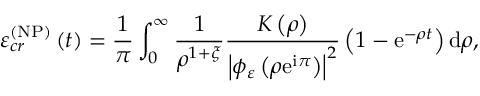<formula> <loc_0><loc_0><loc_500><loc_500>\varepsilon _ { c r } ^ { \left ( N P \right ) } \left ( t \right ) = \frac { 1 } { \pi } \int _ { 0 } ^ { \infty } \frac { 1 } { \rho ^ { 1 + \xi } } \frac { K \left ( \rho \right ) } { \left | \phi _ { \varepsilon } \left ( \rho e ^ { i \pi } \right ) \right | ^ { 2 } } \left ( 1 - e ^ { - \rho t } \right ) d \rho ,</formula> 